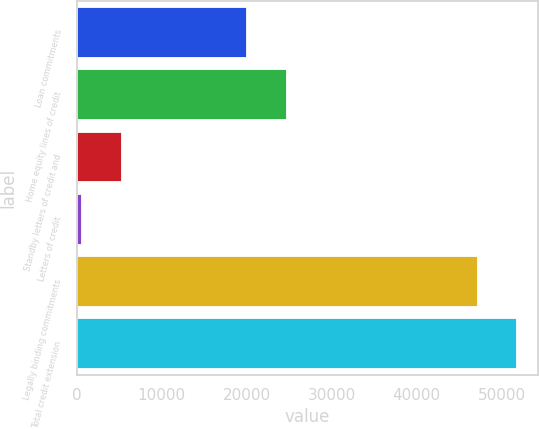<chart> <loc_0><loc_0><loc_500><loc_500><bar_chart><fcel>Loan commitments<fcel>Home equity lines of credit<fcel>Standby letters of credit and<fcel>Letters of credit<fcel>Legally binding commitments<fcel>Total credit extension<nl><fcel>19942<fcel>24596.9<fcel>5200.9<fcel>546<fcel>47095<fcel>51749.9<nl></chart> 